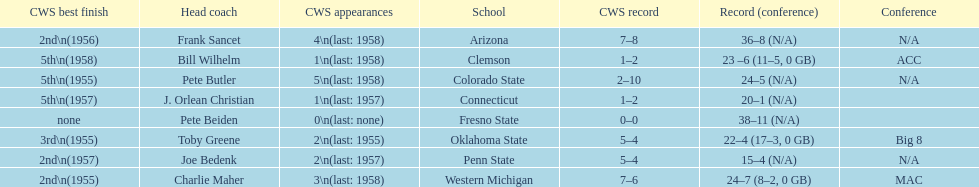How many teams had their cws best finish in 1955? 3. 